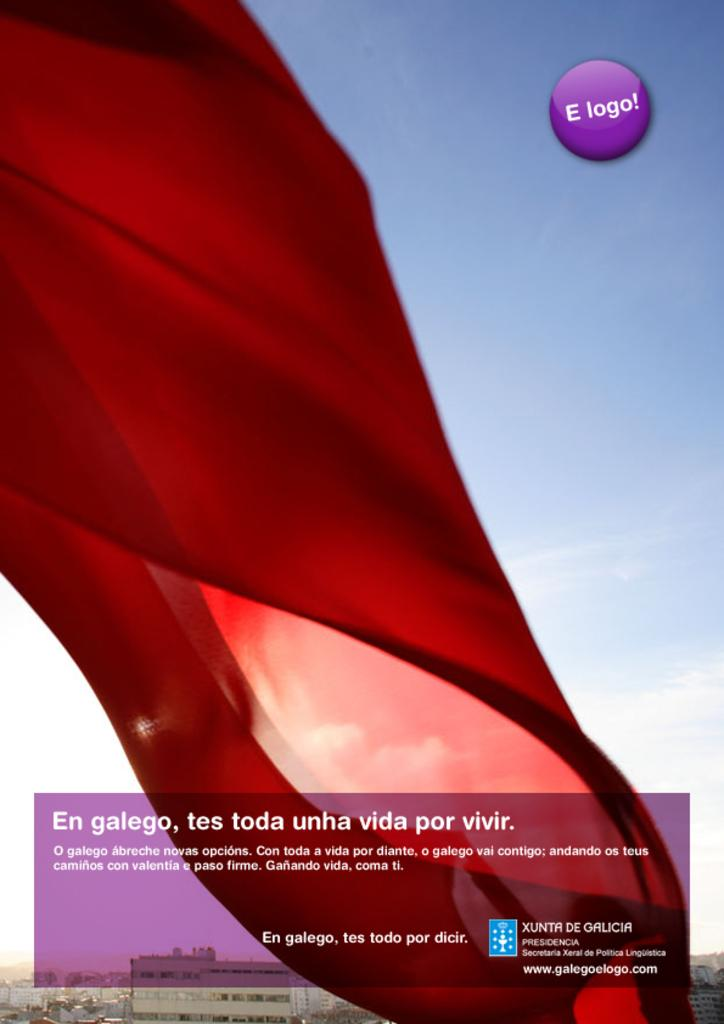<image>
Offer a succinct explanation of the picture presented. An advertisement includes red fabric against the blue sky and a cirlcle with E logo in it. 